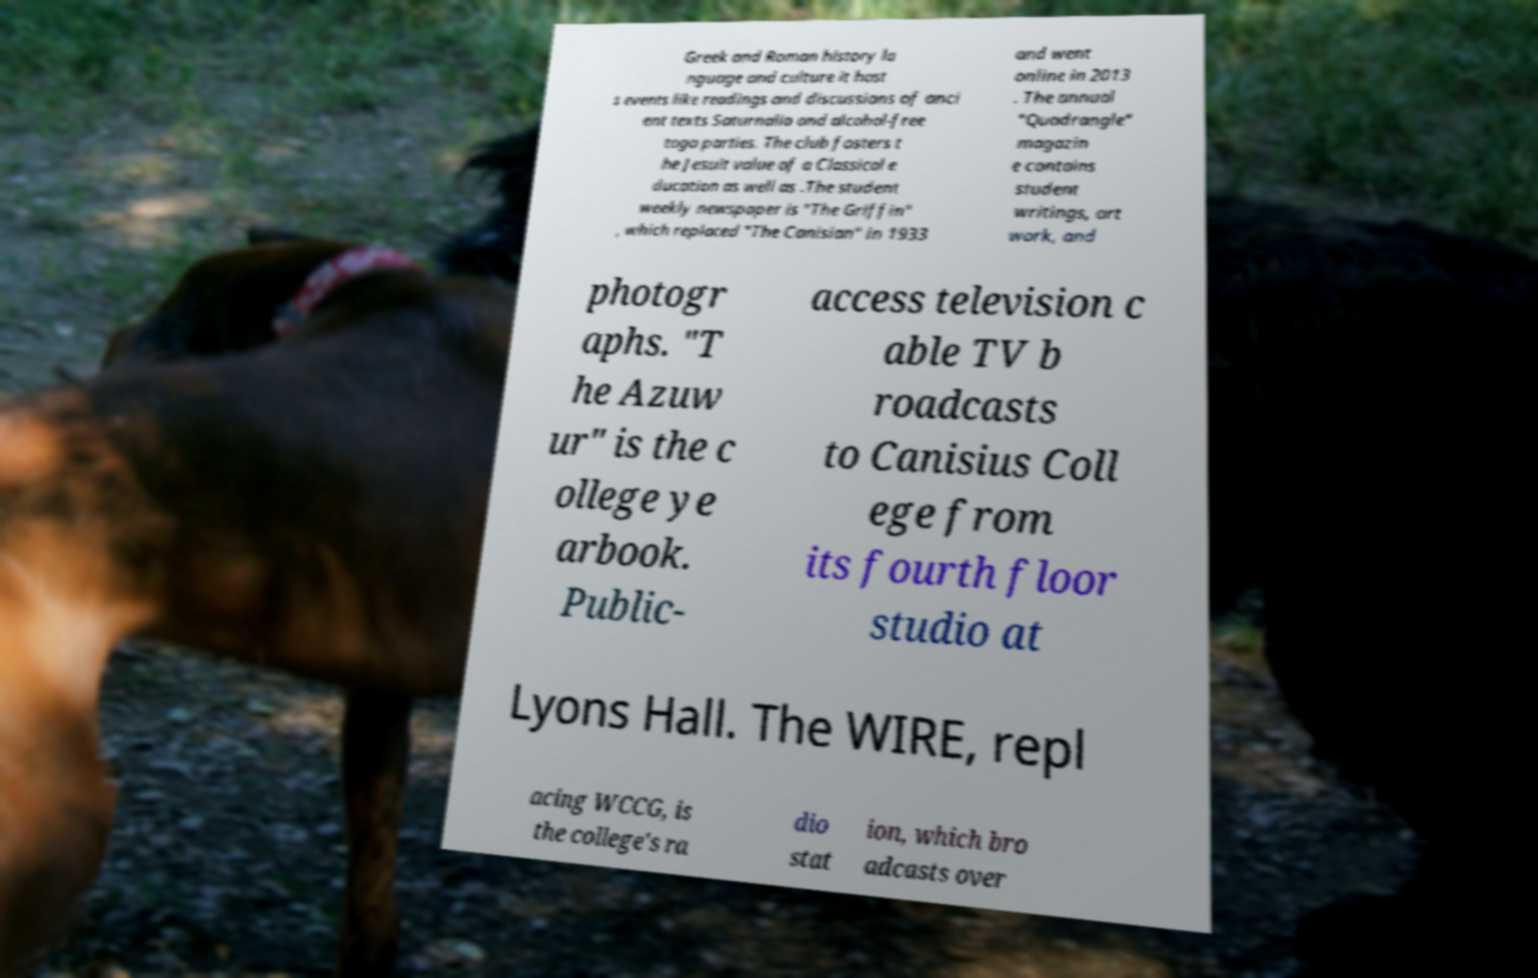There's text embedded in this image that I need extracted. Can you transcribe it verbatim? Greek and Roman history la nguage and culture it host s events like readings and discussions of anci ent texts Saturnalia and alcohol-free toga parties. The club fosters t he Jesuit value of a Classical e ducation as well as .The student weekly newspaper is "The Griffin" , which replaced "The Canisian" in 1933 and went online in 2013 . The annual "Quadrangle" magazin e contains student writings, art work, and photogr aphs. "T he Azuw ur" is the c ollege ye arbook. Public- access television c able TV b roadcasts to Canisius Coll ege from its fourth floor studio at Lyons Hall. The WIRE, repl acing WCCG, is the college's ra dio stat ion, which bro adcasts over 